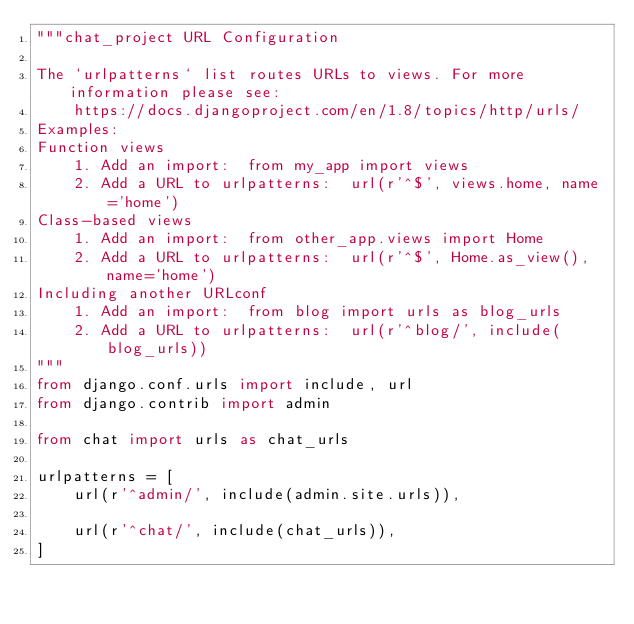Convert code to text. <code><loc_0><loc_0><loc_500><loc_500><_Python_>"""chat_project URL Configuration

The `urlpatterns` list routes URLs to views. For more information please see:
    https://docs.djangoproject.com/en/1.8/topics/http/urls/
Examples:
Function views
    1. Add an import:  from my_app import views
    2. Add a URL to urlpatterns:  url(r'^$', views.home, name='home')
Class-based views
    1. Add an import:  from other_app.views import Home
    2. Add a URL to urlpatterns:  url(r'^$', Home.as_view(), name='home')
Including another URLconf
    1. Add an import:  from blog import urls as blog_urls
    2. Add a URL to urlpatterns:  url(r'^blog/', include(blog_urls))
"""
from django.conf.urls import include, url
from django.contrib import admin

from chat import urls as chat_urls

urlpatterns = [
    url(r'^admin/', include(admin.site.urls)),

    url(r'^chat/', include(chat_urls)),
]
</code> 